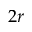Convert formula to latex. <formula><loc_0><loc_0><loc_500><loc_500>2 r</formula> 